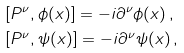<formula> <loc_0><loc_0><loc_500><loc_500>& [ P ^ { \nu } , \phi ( x ) ] = - i \partial ^ { \nu } \phi ( x ) \, , \\ & [ P ^ { \nu } , \psi ( x ) ] = - i \partial ^ { \nu } \psi ( x ) \, ,</formula> 